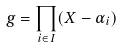<formula> <loc_0><loc_0><loc_500><loc_500>g = \prod _ { i \in I } ( X - \alpha _ { i } )</formula> 